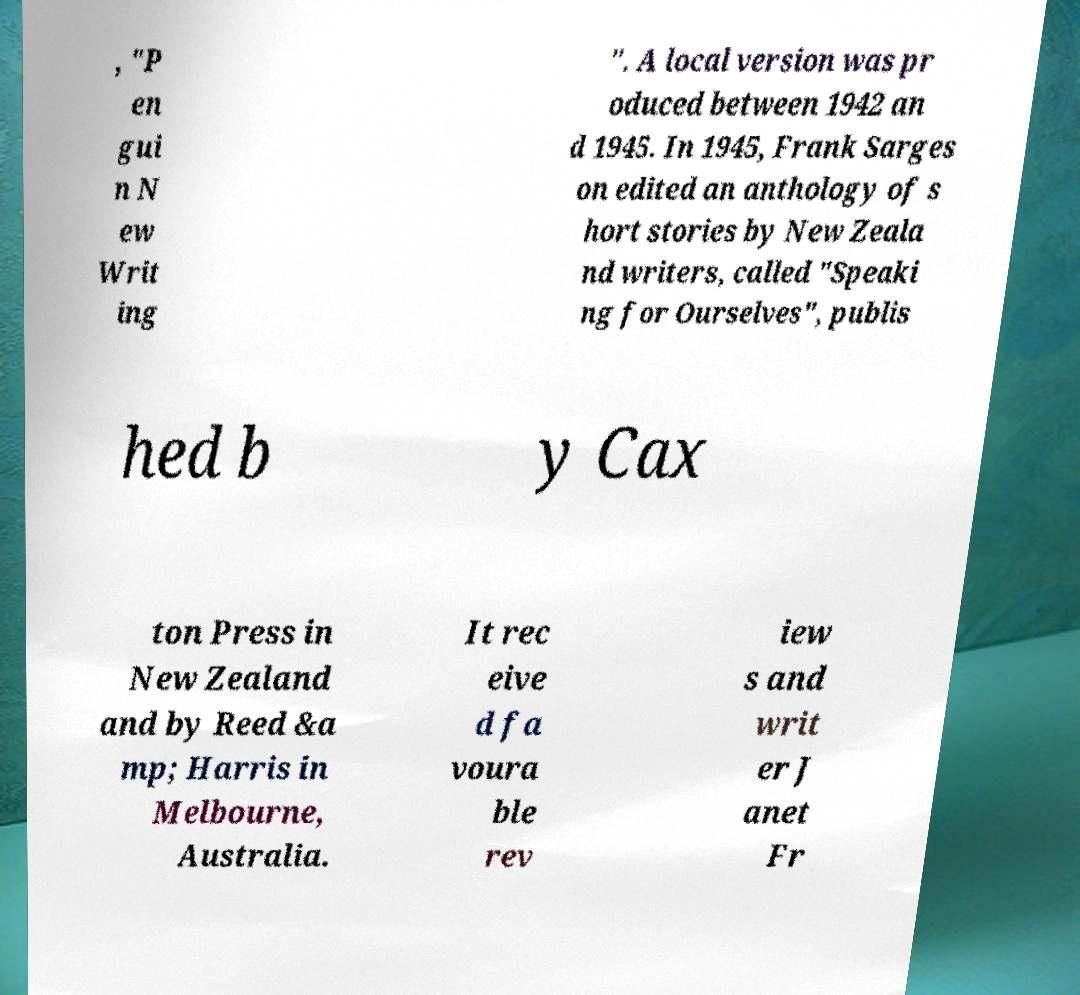Could you assist in decoding the text presented in this image and type it out clearly? , "P en gui n N ew Writ ing ". A local version was pr oduced between 1942 an d 1945. In 1945, Frank Sarges on edited an anthology of s hort stories by New Zeala nd writers, called "Speaki ng for Ourselves", publis hed b y Cax ton Press in New Zealand and by Reed &a mp; Harris in Melbourne, Australia. It rec eive d fa voura ble rev iew s and writ er J anet Fr 